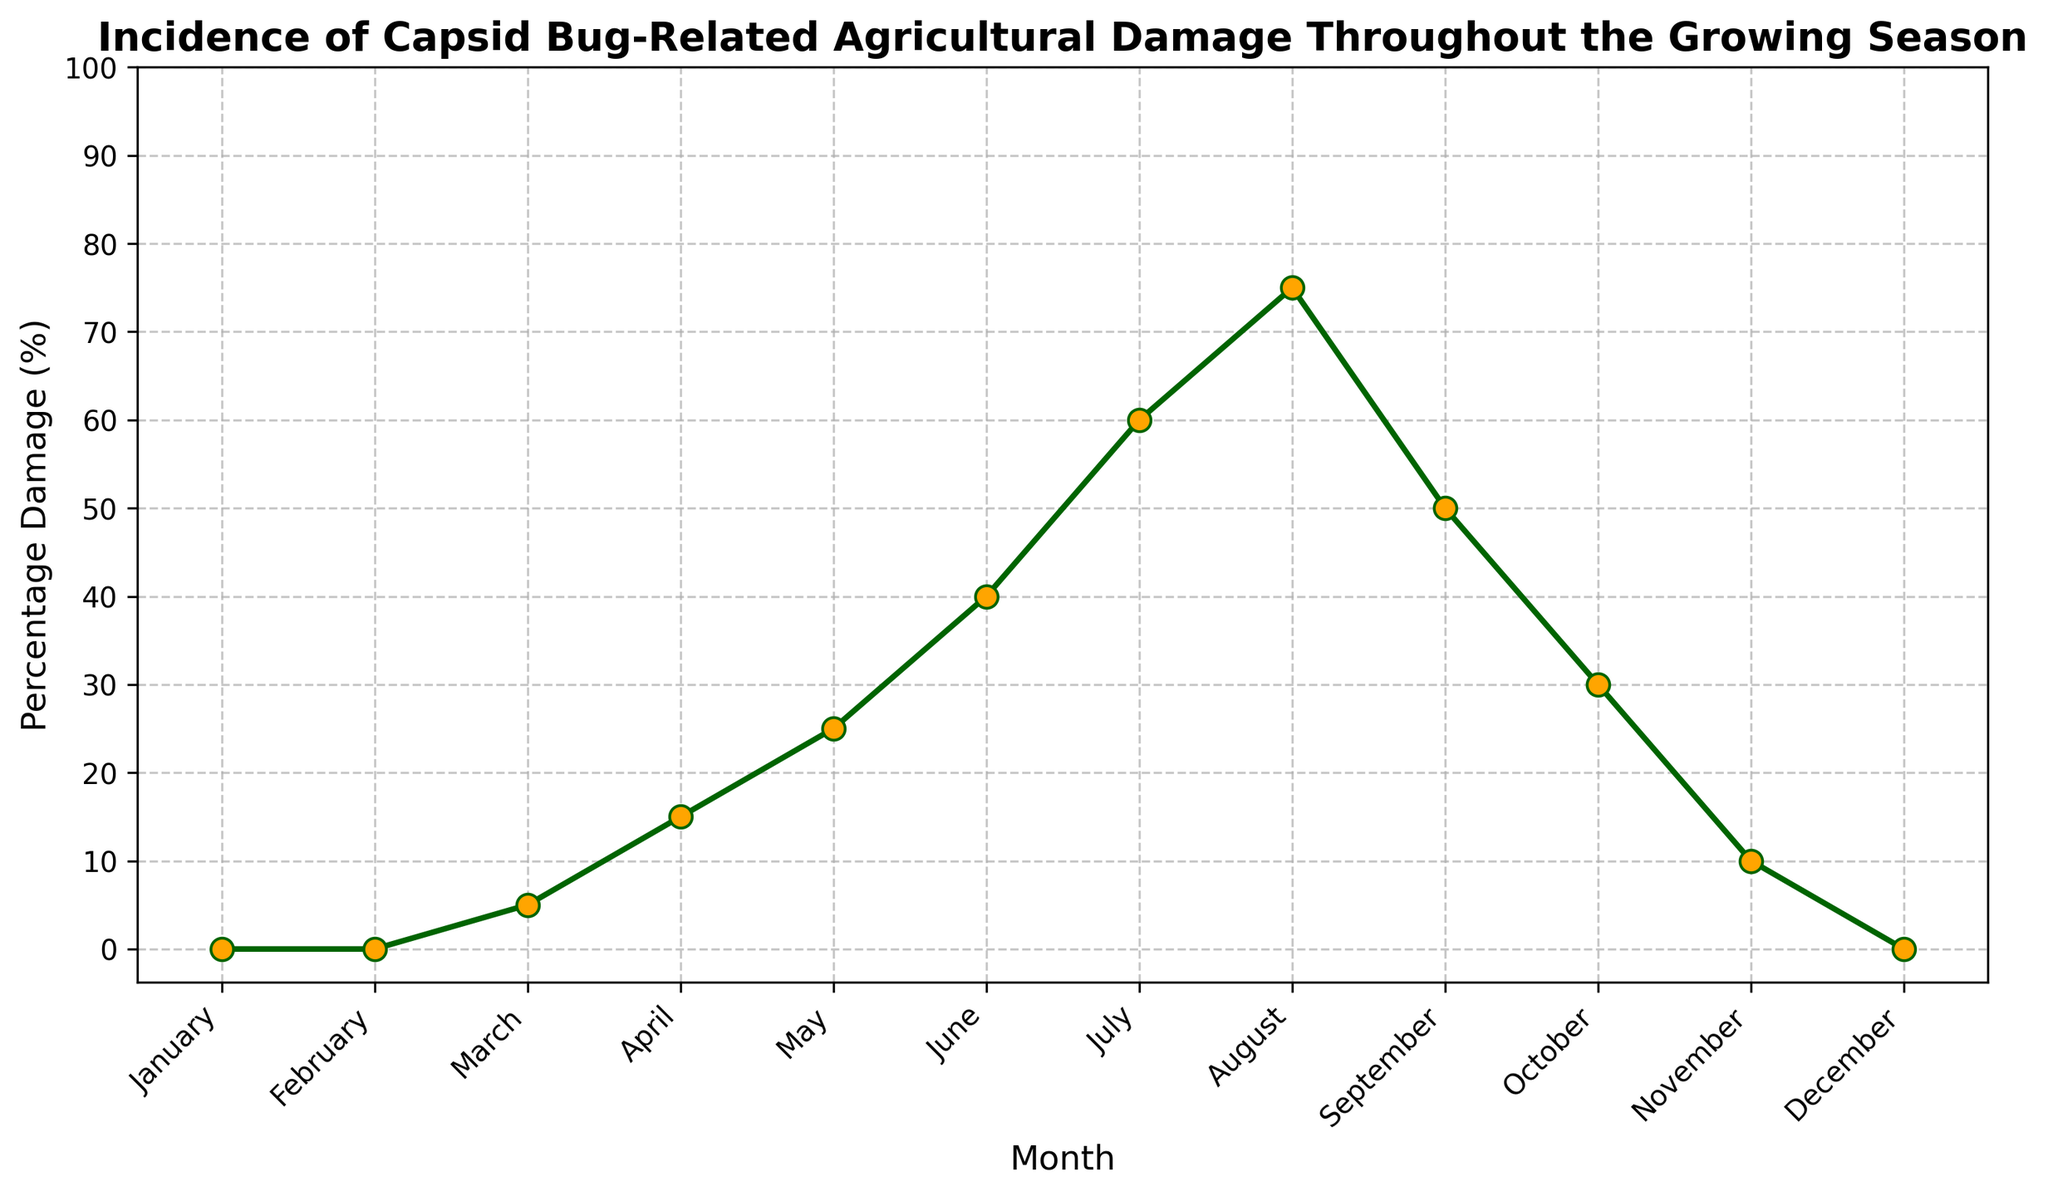What month has the highest percentage of capsid bug-related agricultural damage? To find the month with the highest damage, look for the peak point on the graph. The highest point on the y-axis corresponds to the month of August.
Answer: August By how much did the percentage of damage increase from May to July? In May, the damage is 25%, and in July, it's 60%. Subtract the May value from the July value: 60% - 25% = 35%.
Answer: 35% Which months have zero percentage of capsid bug-related agricultural damage? Look for the months where the percentage value on the y-axis is zero. These months are January, February, and December.
Answer: January, February, December Compare the percentage of damage in June and September. Which month has more damage, and by how much? June has 40% damage, and September has 50% damage. September has more damage by 10% (50% - 40%).
Answer: September, 10% What is the average percentage damage across the entire year? Add up the percentage damage for all months and divide by 12: (0+0+5+15+25+40+60+75+50+30+10+0)/12 = 26%.
Answer: 26% During which part of the year does the damage start to significantly increase? Observe the graph for a noticeable upward trend. The sharp increase starts in April and continues through August.
Answer: April Estimate the total percentage damage accumulated from March to October. Add the monthly percentages from March to October: 5+15+25+40+60+75+50+30 = 300%.
Answer: 300% How does the rate of increase in damage from April to August compare to the rate of decrease from August to December? From April to August (15% to 75%), the increase is 60% over 4 months, which is 15% per month. From August to December (75% to 0%), the decrease is 75% over 4 months, which is roughly 18.75% per month. The rate of decrease is higher.
Answer: Rate of decrease is higher What month marks the onset of capsid bug-related agricultural damage? The damage starts in March, with a percentage of 5%.
Answer: March By how much does the damage decrease from its peak in August to November? The damage in August is 75%, and in November, it is 10%. The decrease is 75% - 10% = 65%.
Answer: 65% 